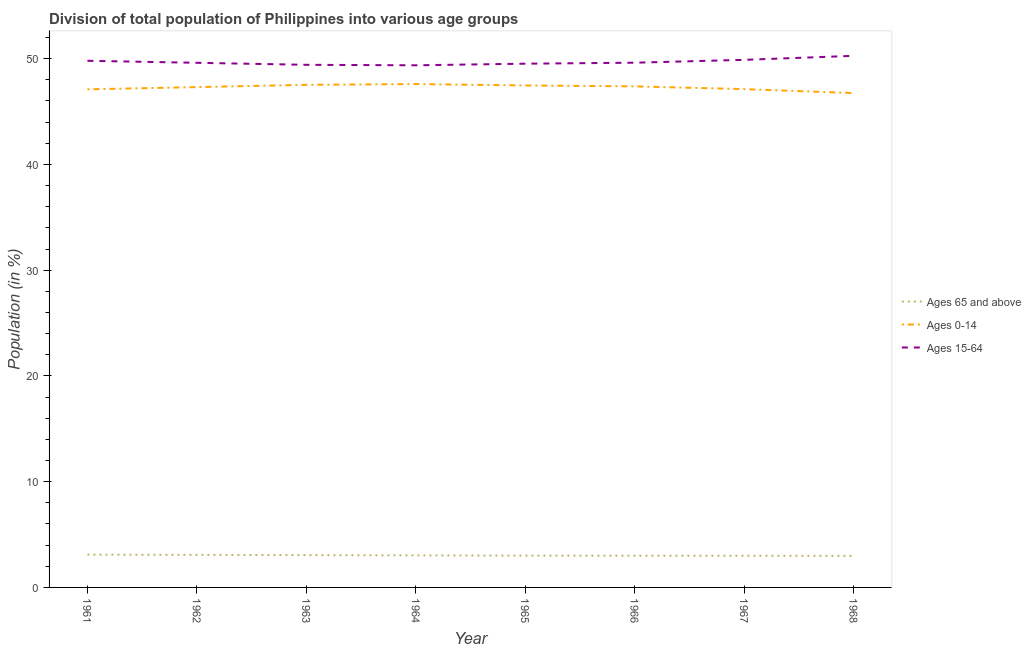Does the line corresponding to percentage of population within the age-group 15-64 intersect with the line corresponding to percentage of population within the age-group of 65 and above?
Make the answer very short. No. What is the percentage of population within the age-group 0-14 in 1964?
Offer a terse response. 47.6. Across all years, what is the maximum percentage of population within the age-group of 65 and above?
Your answer should be very brief. 3.1. Across all years, what is the minimum percentage of population within the age-group 0-14?
Your answer should be very brief. 46.75. In which year was the percentage of population within the age-group 15-64 maximum?
Your response must be concise. 1968. In which year was the percentage of population within the age-group 0-14 minimum?
Offer a terse response. 1968. What is the total percentage of population within the age-group of 65 and above in the graph?
Give a very brief answer. 24.25. What is the difference between the percentage of population within the age-group 0-14 in 1961 and that in 1963?
Offer a very short reply. -0.43. What is the difference between the percentage of population within the age-group 0-14 in 1967 and the percentage of population within the age-group 15-64 in 1964?
Offer a terse response. -2.25. What is the average percentage of population within the age-group 15-64 per year?
Provide a short and direct response. 49.69. In the year 1966, what is the difference between the percentage of population within the age-group 0-14 and percentage of population within the age-group of 65 and above?
Give a very brief answer. 44.38. In how many years, is the percentage of population within the age-group 0-14 greater than 50 %?
Offer a very short reply. 0. What is the ratio of the percentage of population within the age-group 15-64 in 1963 to that in 1965?
Ensure brevity in your answer.  1. What is the difference between the highest and the second highest percentage of population within the age-group 15-64?
Your response must be concise. 0.38. What is the difference between the highest and the lowest percentage of population within the age-group 0-14?
Your answer should be compact. 0.85. Is the sum of the percentage of population within the age-group 15-64 in 1967 and 1968 greater than the maximum percentage of population within the age-group 0-14 across all years?
Keep it short and to the point. Yes. Does the percentage of population within the age-group of 65 and above monotonically increase over the years?
Ensure brevity in your answer.  No. How many lines are there?
Offer a terse response. 3. Are the values on the major ticks of Y-axis written in scientific E-notation?
Keep it short and to the point. No. Does the graph contain any zero values?
Ensure brevity in your answer.  No. Does the graph contain grids?
Your response must be concise. No. Where does the legend appear in the graph?
Ensure brevity in your answer.  Center right. What is the title of the graph?
Provide a short and direct response. Division of total population of Philippines into various age groups
. What is the label or title of the X-axis?
Your response must be concise. Year. What is the label or title of the Y-axis?
Provide a short and direct response. Population (in %). What is the Population (in %) in Ages 65 and above in 1961?
Provide a short and direct response. 3.1. What is the Population (in %) of Ages 0-14 in 1961?
Offer a very short reply. 47.1. What is the Population (in %) of Ages 15-64 in 1961?
Offer a terse response. 49.8. What is the Population (in %) in Ages 65 and above in 1962?
Your answer should be very brief. 3.08. What is the Population (in %) in Ages 0-14 in 1962?
Offer a very short reply. 47.31. What is the Population (in %) in Ages 15-64 in 1962?
Your answer should be compact. 49.61. What is the Population (in %) in Ages 65 and above in 1963?
Your answer should be very brief. 3.06. What is the Population (in %) in Ages 0-14 in 1963?
Your answer should be compact. 47.53. What is the Population (in %) of Ages 15-64 in 1963?
Provide a succinct answer. 49.42. What is the Population (in %) in Ages 65 and above in 1964?
Provide a succinct answer. 3.03. What is the Population (in %) of Ages 0-14 in 1964?
Provide a short and direct response. 47.6. What is the Population (in %) in Ages 15-64 in 1964?
Your answer should be very brief. 49.37. What is the Population (in %) in Ages 65 and above in 1965?
Offer a very short reply. 3.01. What is the Population (in %) in Ages 0-14 in 1965?
Provide a short and direct response. 47.47. What is the Population (in %) in Ages 15-64 in 1965?
Your answer should be very brief. 49.53. What is the Population (in %) in Ages 65 and above in 1966?
Give a very brief answer. 3. What is the Population (in %) in Ages 0-14 in 1966?
Give a very brief answer. 47.38. What is the Population (in %) of Ages 15-64 in 1966?
Provide a succinct answer. 49.62. What is the Population (in %) of Ages 65 and above in 1967?
Offer a terse response. 2.99. What is the Population (in %) in Ages 0-14 in 1967?
Your answer should be very brief. 47.12. What is the Population (in %) of Ages 15-64 in 1967?
Ensure brevity in your answer.  49.89. What is the Population (in %) in Ages 65 and above in 1968?
Provide a short and direct response. 2.99. What is the Population (in %) of Ages 0-14 in 1968?
Your response must be concise. 46.75. What is the Population (in %) in Ages 15-64 in 1968?
Keep it short and to the point. 50.27. Across all years, what is the maximum Population (in %) in Ages 65 and above?
Provide a succinct answer. 3.1. Across all years, what is the maximum Population (in %) in Ages 0-14?
Provide a short and direct response. 47.6. Across all years, what is the maximum Population (in %) in Ages 15-64?
Offer a very short reply. 50.27. Across all years, what is the minimum Population (in %) of Ages 65 and above?
Ensure brevity in your answer.  2.99. Across all years, what is the minimum Population (in %) of Ages 0-14?
Provide a short and direct response. 46.75. Across all years, what is the minimum Population (in %) in Ages 15-64?
Ensure brevity in your answer.  49.37. What is the total Population (in %) of Ages 65 and above in the graph?
Provide a succinct answer. 24.25. What is the total Population (in %) of Ages 0-14 in the graph?
Provide a short and direct response. 378.25. What is the total Population (in %) of Ages 15-64 in the graph?
Offer a terse response. 397.5. What is the difference between the Population (in %) of Ages 65 and above in 1961 and that in 1962?
Offer a very short reply. 0.02. What is the difference between the Population (in %) in Ages 0-14 in 1961 and that in 1962?
Make the answer very short. -0.21. What is the difference between the Population (in %) of Ages 15-64 in 1961 and that in 1962?
Your response must be concise. 0.19. What is the difference between the Population (in %) in Ages 65 and above in 1961 and that in 1963?
Make the answer very short. 0.04. What is the difference between the Population (in %) of Ages 0-14 in 1961 and that in 1963?
Offer a very short reply. -0.43. What is the difference between the Population (in %) of Ages 15-64 in 1961 and that in 1963?
Your response must be concise. 0.38. What is the difference between the Population (in %) of Ages 65 and above in 1961 and that in 1964?
Ensure brevity in your answer.  0.07. What is the difference between the Population (in %) of Ages 0-14 in 1961 and that in 1964?
Offer a terse response. -0.5. What is the difference between the Population (in %) in Ages 15-64 in 1961 and that in 1964?
Provide a succinct answer. 0.43. What is the difference between the Population (in %) of Ages 65 and above in 1961 and that in 1965?
Offer a very short reply. 0.09. What is the difference between the Population (in %) in Ages 0-14 in 1961 and that in 1965?
Your answer should be compact. -0.37. What is the difference between the Population (in %) in Ages 15-64 in 1961 and that in 1965?
Offer a very short reply. 0.28. What is the difference between the Population (in %) of Ages 65 and above in 1961 and that in 1966?
Keep it short and to the point. 0.1. What is the difference between the Population (in %) in Ages 0-14 in 1961 and that in 1966?
Give a very brief answer. -0.28. What is the difference between the Population (in %) in Ages 15-64 in 1961 and that in 1966?
Provide a short and direct response. 0.18. What is the difference between the Population (in %) in Ages 65 and above in 1961 and that in 1967?
Provide a short and direct response. 0.11. What is the difference between the Population (in %) of Ages 0-14 in 1961 and that in 1967?
Ensure brevity in your answer.  -0.02. What is the difference between the Population (in %) of Ages 15-64 in 1961 and that in 1967?
Offer a very short reply. -0.09. What is the difference between the Population (in %) in Ages 65 and above in 1961 and that in 1968?
Make the answer very short. 0.11. What is the difference between the Population (in %) of Ages 0-14 in 1961 and that in 1968?
Your response must be concise. 0.35. What is the difference between the Population (in %) in Ages 15-64 in 1961 and that in 1968?
Provide a succinct answer. -0.47. What is the difference between the Population (in %) in Ages 65 and above in 1962 and that in 1963?
Provide a succinct answer. 0.02. What is the difference between the Population (in %) of Ages 0-14 in 1962 and that in 1963?
Your answer should be compact. -0.21. What is the difference between the Population (in %) of Ages 15-64 in 1962 and that in 1963?
Make the answer very short. 0.19. What is the difference between the Population (in %) of Ages 65 and above in 1962 and that in 1964?
Keep it short and to the point. 0.05. What is the difference between the Population (in %) in Ages 0-14 in 1962 and that in 1964?
Provide a short and direct response. -0.29. What is the difference between the Population (in %) of Ages 15-64 in 1962 and that in 1964?
Ensure brevity in your answer.  0.24. What is the difference between the Population (in %) in Ages 65 and above in 1962 and that in 1965?
Provide a short and direct response. 0.07. What is the difference between the Population (in %) in Ages 0-14 in 1962 and that in 1965?
Your answer should be compact. -0.16. What is the difference between the Population (in %) of Ages 15-64 in 1962 and that in 1965?
Keep it short and to the point. 0.08. What is the difference between the Population (in %) of Ages 65 and above in 1962 and that in 1966?
Offer a very short reply. 0.08. What is the difference between the Population (in %) in Ages 0-14 in 1962 and that in 1966?
Your response must be concise. -0.07. What is the difference between the Population (in %) of Ages 15-64 in 1962 and that in 1966?
Your response must be concise. -0.01. What is the difference between the Population (in %) in Ages 65 and above in 1962 and that in 1967?
Provide a short and direct response. 0.09. What is the difference between the Population (in %) in Ages 0-14 in 1962 and that in 1967?
Make the answer very short. 0.19. What is the difference between the Population (in %) of Ages 15-64 in 1962 and that in 1967?
Keep it short and to the point. -0.28. What is the difference between the Population (in %) of Ages 65 and above in 1962 and that in 1968?
Give a very brief answer. 0.09. What is the difference between the Population (in %) of Ages 0-14 in 1962 and that in 1968?
Ensure brevity in your answer.  0.57. What is the difference between the Population (in %) in Ages 15-64 in 1962 and that in 1968?
Make the answer very short. -0.66. What is the difference between the Population (in %) in Ages 65 and above in 1963 and that in 1964?
Your answer should be very brief. 0.03. What is the difference between the Population (in %) in Ages 0-14 in 1963 and that in 1964?
Keep it short and to the point. -0.07. What is the difference between the Population (in %) of Ages 15-64 in 1963 and that in 1964?
Provide a succinct answer. 0.05. What is the difference between the Population (in %) in Ages 65 and above in 1963 and that in 1965?
Provide a succinct answer. 0.05. What is the difference between the Population (in %) of Ages 0-14 in 1963 and that in 1965?
Give a very brief answer. 0.06. What is the difference between the Population (in %) of Ages 15-64 in 1963 and that in 1965?
Ensure brevity in your answer.  -0.11. What is the difference between the Population (in %) of Ages 65 and above in 1963 and that in 1966?
Offer a terse response. 0.05. What is the difference between the Population (in %) in Ages 0-14 in 1963 and that in 1966?
Provide a short and direct response. 0.15. What is the difference between the Population (in %) in Ages 15-64 in 1963 and that in 1966?
Offer a terse response. -0.2. What is the difference between the Population (in %) of Ages 65 and above in 1963 and that in 1967?
Offer a terse response. 0.06. What is the difference between the Population (in %) in Ages 0-14 in 1963 and that in 1967?
Offer a very short reply. 0.41. What is the difference between the Population (in %) in Ages 15-64 in 1963 and that in 1967?
Provide a succinct answer. -0.47. What is the difference between the Population (in %) in Ages 65 and above in 1963 and that in 1968?
Provide a succinct answer. 0.07. What is the difference between the Population (in %) of Ages 0-14 in 1963 and that in 1968?
Give a very brief answer. 0.78. What is the difference between the Population (in %) in Ages 15-64 in 1963 and that in 1968?
Make the answer very short. -0.85. What is the difference between the Population (in %) of Ages 65 and above in 1964 and that in 1965?
Provide a succinct answer. 0.02. What is the difference between the Population (in %) of Ages 0-14 in 1964 and that in 1965?
Ensure brevity in your answer.  0.13. What is the difference between the Population (in %) in Ages 15-64 in 1964 and that in 1965?
Keep it short and to the point. -0.15. What is the difference between the Population (in %) of Ages 65 and above in 1964 and that in 1966?
Your response must be concise. 0.03. What is the difference between the Population (in %) of Ages 0-14 in 1964 and that in 1966?
Your answer should be very brief. 0.22. What is the difference between the Population (in %) of Ages 15-64 in 1964 and that in 1966?
Ensure brevity in your answer.  -0.25. What is the difference between the Population (in %) in Ages 65 and above in 1964 and that in 1967?
Provide a succinct answer. 0.04. What is the difference between the Population (in %) of Ages 0-14 in 1964 and that in 1967?
Provide a succinct answer. 0.48. What is the difference between the Population (in %) in Ages 15-64 in 1964 and that in 1967?
Your answer should be very brief. -0.51. What is the difference between the Population (in %) in Ages 65 and above in 1964 and that in 1968?
Provide a short and direct response. 0.04. What is the difference between the Population (in %) of Ages 0-14 in 1964 and that in 1968?
Offer a terse response. 0.85. What is the difference between the Population (in %) in Ages 15-64 in 1964 and that in 1968?
Your answer should be compact. -0.9. What is the difference between the Population (in %) of Ages 65 and above in 1965 and that in 1966?
Give a very brief answer. 0.01. What is the difference between the Population (in %) in Ages 0-14 in 1965 and that in 1966?
Provide a succinct answer. 0.09. What is the difference between the Population (in %) in Ages 15-64 in 1965 and that in 1966?
Your answer should be compact. -0.09. What is the difference between the Population (in %) of Ages 65 and above in 1965 and that in 1967?
Keep it short and to the point. 0.01. What is the difference between the Population (in %) in Ages 0-14 in 1965 and that in 1967?
Your answer should be very brief. 0.35. What is the difference between the Population (in %) of Ages 15-64 in 1965 and that in 1967?
Your answer should be very brief. -0.36. What is the difference between the Population (in %) of Ages 65 and above in 1965 and that in 1968?
Offer a very short reply. 0.02. What is the difference between the Population (in %) of Ages 0-14 in 1965 and that in 1968?
Your response must be concise. 0.72. What is the difference between the Population (in %) of Ages 15-64 in 1965 and that in 1968?
Offer a terse response. -0.74. What is the difference between the Population (in %) of Ages 65 and above in 1966 and that in 1967?
Your answer should be compact. 0.01. What is the difference between the Population (in %) in Ages 0-14 in 1966 and that in 1967?
Offer a very short reply. 0.26. What is the difference between the Population (in %) of Ages 15-64 in 1966 and that in 1967?
Offer a terse response. -0.27. What is the difference between the Population (in %) of Ages 65 and above in 1966 and that in 1968?
Keep it short and to the point. 0.02. What is the difference between the Population (in %) in Ages 0-14 in 1966 and that in 1968?
Keep it short and to the point. 0.63. What is the difference between the Population (in %) of Ages 15-64 in 1966 and that in 1968?
Your answer should be very brief. -0.65. What is the difference between the Population (in %) of Ages 65 and above in 1967 and that in 1968?
Offer a very short reply. 0.01. What is the difference between the Population (in %) of Ages 0-14 in 1967 and that in 1968?
Your response must be concise. 0.37. What is the difference between the Population (in %) in Ages 15-64 in 1967 and that in 1968?
Offer a very short reply. -0.38. What is the difference between the Population (in %) in Ages 65 and above in 1961 and the Population (in %) in Ages 0-14 in 1962?
Offer a very short reply. -44.21. What is the difference between the Population (in %) of Ages 65 and above in 1961 and the Population (in %) of Ages 15-64 in 1962?
Your answer should be compact. -46.51. What is the difference between the Population (in %) of Ages 0-14 in 1961 and the Population (in %) of Ages 15-64 in 1962?
Your response must be concise. -2.51. What is the difference between the Population (in %) of Ages 65 and above in 1961 and the Population (in %) of Ages 0-14 in 1963?
Ensure brevity in your answer.  -44.43. What is the difference between the Population (in %) in Ages 65 and above in 1961 and the Population (in %) in Ages 15-64 in 1963?
Your answer should be compact. -46.32. What is the difference between the Population (in %) of Ages 0-14 in 1961 and the Population (in %) of Ages 15-64 in 1963?
Provide a succinct answer. -2.32. What is the difference between the Population (in %) in Ages 65 and above in 1961 and the Population (in %) in Ages 0-14 in 1964?
Provide a succinct answer. -44.5. What is the difference between the Population (in %) in Ages 65 and above in 1961 and the Population (in %) in Ages 15-64 in 1964?
Provide a succinct answer. -46.27. What is the difference between the Population (in %) of Ages 0-14 in 1961 and the Population (in %) of Ages 15-64 in 1964?
Your answer should be compact. -2.27. What is the difference between the Population (in %) of Ages 65 and above in 1961 and the Population (in %) of Ages 0-14 in 1965?
Your answer should be compact. -44.37. What is the difference between the Population (in %) of Ages 65 and above in 1961 and the Population (in %) of Ages 15-64 in 1965?
Offer a terse response. -46.43. What is the difference between the Population (in %) in Ages 0-14 in 1961 and the Population (in %) in Ages 15-64 in 1965?
Make the answer very short. -2.42. What is the difference between the Population (in %) in Ages 65 and above in 1961 and the Population (in %) in Ages 0-14 in 1966?
Provide a succinct answer. -44.28. What is the difference between the Population (in %) of Ages 65 and above in 1961 and the Population (in %) of Ages 15-64 in 1966?
Give a very brief answer. -46.52. What is the difference between the Population (in %) in Ages 0-14 in 1961 and the Population (in %) in Ages 15-64 in 1966?
Offer a very short reply. -2.52. What is the difference between the Population (in %) of Ages 65 and above in 1961 and the Population (in %) of Ages 0-14 in 1967?
Provide a short and direct response. -44.02. What is the difference between the Population (in %) of Ages 65 and above in 1961 and the Population (in %) of Ages 15-64 in 1967?
Your answer should be very brief. -46.79. What is the difference between the Population (in %) of Ages 0-14 in 1961 and the Population (in %) of Ages 15-64 in 1967?
Your answer should be very brief. -2.79. What is the difference between the Population (in %) in Ages 65 and above in 1961 and the Population (in %) in Ages 0-14 in 1968?
Give a very brief answer. -43.65. What is the difference between the Population (in %) of Ages 65 and above in 1961 and the Population (in %) of Ages 15-64 in 1968?
Provide a succinct answer. -47.17. What is the difference between the Population (in %) in Ages 0-14 in 1961 and the Population (in %) in Ages 15-64 in 1968?
Give a very brief answer. -3.17. What is the difference between the Population (in %) in Ages 65 and above in 1962 and the Population (in %) in Ages 0-14 in 1963?
Offer a very short reply. -44.45. What is the difference between the Population (in %) of Ages 65 and above in 1962 and the Population (in %) of Ages 15-64 in 1963?
Give a very brief answer. -46.34. What is the difference between the Population (in %) in Ages 0-14 in 1962 and the Population (in %) in Ages 15-64 in 1963?
Make the answer very short. -2.11. What is the difference between the Population (in %) in Ages 65 and above in 1962 and the Population (in %) in Ages 0-14 in 1964?
Keep it short and to the point. -44.52. What is the difference between the Population (in %) in Ages 65 and above in 1962 and the Population (in %) in Ages 15-64 in 1964?
Offer a very short reply. -46.29. What is the difference between the Population (in %) of Ages 0-14 in 1962 and the Population (in %) of Ages 15-64 in 1964?
Your response must be concise. -2.06. What is the difference between the Population (in %) of Ages 65 and above in 1962 and the Population (in %) of Ages 0-14 in 1965?
Offer a very short reply. -44.39. What is the difference between the Population (in %) in Ages 65 and above in 1962 and the Population (in %) in Ages 15-64 in 1965?
Your answer should be very brief. -46.45. What is the difference between the Population (in %) in Ages 0-14 in 1962 and the Population (in %) in Ages 15-64 in 1965?
Make the answer very short. -2.21. What is the difference between the Population (in %) of Ages 65 and above in 1962 and the Population (in %) of Ages 0-14 in 1966?
Provide a short and direct response. -44.3. What is the difference between the Population (in %) in Ages 65 and above in 1962 and the Population (in %) in Ages 15-64 in 1966?
Provide a short and direct response. -46.54. What is the difference between the Population (in %) of Ages 0-14 in 1962 and the Population (in %) of Ages 15-64 in 1966?
Make the answer very short. -2.31. What is the difference between the Population (in %) in Ages 65 and above in 1962 and the Population (in %) in Ages 0-14 in 1967?
Ensure brevity in your answer.  -44.04. What is the difference between the Population (in %) of Ages 65 and above in 1962 and the Population (in %) of Ages 15-64 in 1967?
Your answer should be compact. -46.81. What is the difference between the Population (in %) of Ages 0-14 in 1962 and the Population (in %) of Ages 15-64 in 1967?
Your answer should be very brief. -2.58. What is the difference between the Population (in %) of Ages 65 and above in 1962 and the Population (in %) of Ages 0-14 in 1968?
Provide a short and direct response. -43.67. What is the difference between the Population (in %) of Ages 65 and above in 1962 and the Population (in %) of Ages 15-64 in 1968?
Offer a terse response. -47.19. What is the difference between the Population (in %) of Ages 0-14 in 1962 and the Population (in %) of Ages 15-64 in 1968?
Your answer should be very brief. -2.96. What is the difference between the Population (in %) in Ages 65 and above in 1963 and the Population (in %) in Ages 0-14 in 1964?
Your answer should be very brief. -44.54. What is the difference between the Population (in %) in Ages 65 and above in 1963 and the Population (in %) in Ages 15-64 in 1964?
Keep it short and to the point. -46.32. What is the difference between the Population (in %) in Ages 0-14 in 1963 and the Population (in %) in Ages 15-64 in 1964?
Provide a short and direct response. -1.85. What is the difference between the Population (in %) of Ages 65 and above in 1963 and the Population (in %) of Ages 0-14 in 1965?
Your response must be concise. -44.41. What is the difference between the Population (in %) in Ages 65 and above in 1963 and the Population (in %) in Ages 15-64 in 1965?
Your response must be concise. -46.47. What is the difference between the Population (in %) of Ages 0-14 in 1963 and the Population (in %) of Ages 15-64 in 1965?
Your answer should be very brief. -2. What is the difference between the Population (in %) of Ages 65 and above in 1963 and the Population (in %) of Ages 0-14 in 1966?
Offer a terse response. -44.32. What is the difference between the Population (in %) of Ages 65 and above in 1963 and the Population (in %) of Ages 15-64 in 1966?
Give a very brief answer. -46.56. What is the difference between the Population (in %) of Ages 0-14 in 1963 and the Population (in %) of Ages 15-64 in 1966?
Provide a short and direct response. -2.09. What is the difference between the Population (in %) of Ages 65 and above in 1963 and the Population (in %) of Ages 0-14 in 1967?
Your response must be concise. -44.06. What is the difference between the Population (in %) of Ages 65 and above in 1963 and the Population (in %) of Ages 15-64 in 1967?
Make the answer very short. -46.83. What is the difference between the Population (in %) in Ages 0-14 in 1963 and the Population (in %) in Ages 15-64 in 1967?
Offer a very short reply. -2.36. What is the difference between the Population (in %) of Ages 65 and above in 1963 and the Population (in %) of Ages 0-14 in 1968?
Your answer should be very brief. -43.69. What is the difference between the Population (in %) in Ages 65 and above in 1963 and the Population (in %) in Ages 15-64 in 1968?
Provide a short and direct response. -47.21. What is the difference between the Population (in %) of Ages 0-14 in 1963 and the Population (in %) of Ages 15-64 in 1968?
Your answer should be compact. -2.74. What is the difference between the Population (in %) of Ages 65 and above in 1964 and the Population (in %) of Ages 0-14 in 1965?
Your answer should be very brief. -44.44. What is the difference between the Population (in %) in Ages 65 and above in 1964 and the Population (in %) in Ages 15-64 in 1965?
Your answer should be very brief. -46.49. What is the difference between the Population (in %) of Ages 0-14 in 1964 and the Population (in %) of Ages 15-64 in 1965?
Offer a terse response. -1.93. What is the difference between the Population (in %) in Ages 65 and above in 1964 and the Population (in %) in Ages 0-14 in 1966?
Your answer should be very brief. -44.35. What is the difference between the Population (in %) in Ages 65 and above in 1964 and the Population (in %) in Ages 15-64 in 1966?
Give a very brief answer. -46.59. What is the difference between the Population (in %) in Ages 0-14 in 1964 and the Population (in %) in Ages 15-64 in 1966?
Keep it short and to the point. -2.02. What is the difference between the Population (in %) in Ages 65 and above in 1964 and the Population (in %) in Ages 0-14 in 1967?
Your answer should be very brief. -44.09. What is the difference between the Population (in %) in Ages 65 and above in 1964 and the Population (in %) in Ages 15-64 in 1967?
Provide a succinct answer. -46.86. What is the difference between the Population (in %) of Ages 0-14 in 1964 and the Population (in %) of Ages 15-64 in 1967?
Make the answer very short. -2.29. What is the difference between the Population (in %) of Ages 65 and above in 1964 and the Population (in %) of Ages 0-14 in 1968?
Your response must be concise. -43.72. What is the difference between the Population (in %) of Ages 65 and above in 1964 and the Population (in %) of Ages 15-64 in 1968?
Provide a short and direct response. -47.24. What is the difference between the Population (in %) of Ages 0-14 in 1964 and the Population (in %) of Ages 15-64 in 1968?
Your response must be concise. -2.67. What is the difference between the Population (in %) in Ages 65 and above in 1965 and the Population (in %) in Ages 0-14 in 1966?
Offer a very short reply. -44.37. What is the difference between the Population (in %) in Ages 65 and above in 1965 and the Population (in %) in Ages 15-64 in 1966?
Your answer should be very brief. -46.61. What is the difference between the Population (in %) in Ages 0-14 in 1965 and the Population (in %) in Ages 15-64 in 1966?
Offer a terse response. -2.15. What is the difference between the Population (in %) of Ages 65 and above in 1965 and the Population (in %) of Ages 0-14 in 1967?
Give a very brief answer. -44.11. What is the difference between the Population (in %) of Ages 65 and above in 1965 and the Population (in %) of Ages 15-64 in 1967?
Provide a succinct answer. -46.88. What is the difference between the Population (in %) of Ages 0-14 in 1965 and the Population (in %) of Ages 15-64 in 1967?
Your response must be concise. -2.42. What is the difference between the Population (in %) in Ages 65 and above in 1965 and the Population (in %) in Ages 0-14 in 1968?
Your answer should be compact. -43.74. What is the difference between the Population (in %) of Ages 65 and above in 1965 and the Population (in %) of Ages 15-64 in 1968?
Provide a short and direct response. -47.26. What is the difference between the Population (in %) of Ages 0-14 in 1965 and the Population (in %) of Ages 15-64 in 1968?
Your response must be concise. -2.8. What is the difference between the Population (in %) in Ages 65 and above in 1966 and the Population (in %) in Ages 0-14 in 1967?
Your answer should be compact. -44.12. What is the difference between the Population (in %) in Ages 65 and above in 1966 and the Population (in %) in Ages 15-64 in 1967?
Provide a short and direct response. -46.89. What is the difference between the Population (in %) in Ages 0-14 in 1966 and the Population (in %) in Ages 15-64 in 1967?
Your answer should be compact. -2.51. What is the difference between the Population (in %) in Ages 65 and above in 1966 and the Population (in %) in Ages 0-14 in 1968?
Offer a very short reply. -43.74. What is the difference between the Population (in %) of Ages 65 and above in 1966 and the Population (in %) of Ages 15-64 in 1968?
Give a very brief answer. -47.27. What is the difference between the Population (in %) of Ages 0-14 in 1966 and the Population (in %) of Ages 15-64 in 1968?
Make the answer very short. -2.89. What is the difference between the Population (in %) in Ages 65 and above in 1967 and the Population (in %) in Ages 0-14 in 1968?
Provide a succinct answer. -43.75. What is the difference between the Population (in %) in Ages 65 and above in 1967 and the Population (in %) in Ages 15-64 in 1968?
Offer a terse response. -47.28. What is the difference between the Population (in %) in Ages 0-14 in 1967 and the Population (in %) in Ages 15-64 in 1968?
Your response must be concise. -3.15. What is the average Population (in %) of Ages 65 and above per year?
Offer a terse response. 3.03. What is the average Population (in %) of Ages 0-14 per year?
Provide a succinct answer. 47.28. What is the average Population (in %) of Ages 15-64 per year?
Offer a terse response. 49.69. In the year 1961, what is the difference between the Population (in %) in Ages 65 and above and Population (in %) in Ages 0-14?
Offer a terse response. -44. In the year 1961, what is the difference between the Population (in %) in Ages 65 and above and Population (in %) in Ages 15-64?
Ensure brevity in your answer.  -46.7. In the year 1961, what is the difference between the Population (in %) of Ages 0-14 and Population (in %) of Ages 15-64?
Provide a short and direct response. -2.7. In the year 1962, what is the difference between the Population (in %) of Ages 65 and above and Population (in %) of Ages 0-14?
Your response must be concise. -44.23. In the year 1962, what is the difference between the Population (in %) of Ages 65 and above and Population (in %) of Ages 15-64?
Your answer should be very brief. -46.53. In the year 1962, what is the difference between the Population (in %) in Ages 0-14 and Population (in %) in Ages 15-64?
Your response must be concise. -2.3. In the year 1963, what is the difference between the Population (in %) in Ages 65 and above and Population (in %) in Ages 0-14?
Your response must be concise. -44.47. In the year 1963, what is the difference between the Population (in %) of Ages 65 and above and Population (in %) of Ages 15-64?
Provide a succinct answer. -46.36. In the year 1963, what is the difference between the Population (in %) in Ages 0-14 and Population (in %) in Ages 15-64?
Keep it short and to the point. -1.89. In the year 1964, what is the difference between the Population (in %) of Ages 65 and above and Population (in %) of Ages 0-14?
Provide a short and direct response. -44.57. In the year 1964, what is the difference between the Population (in %) of Ages 65 and above and Population (in %) of Ages 15-64?
Give a very brief answer. -46.34. In the year 1964, what is the difference between the Population (in %) in Ages 0-14 and Population (in %) in Ages 15-64?
Provide a succinct answer. -1.78. In the year 1965, what is the difference between the Population (in %) in Ages 65 and above and Population (in %) in Ages 0-14?
Provide a short and direct response. -44.46. In the year 1965, what is the difference between the Population (in %) of Ages 65 and above and Population (in %) of Ages 15-64?
Offer a very short reply. -46.52. In the year 1965, what is the difference between the Population (in %) of Ages 0-14 and Population (in %) of Ages 15-64?
Provide a short and direct response. -2.06. In the year 1966, what is the difference between the Population (in %) of Ages 65 and above and Population (in %) of Ages 0-14?
Your answer should be very brief. -44.38. In the year 1966, what is the difference between the Population (in %) of Ages 65 and above and Population (in %) of Ages 15-64?
Give a very brief answer. -46.62. In the year 1966, what is the difference between the Population (in %) of Ages 0-14 and Population (in %) of Ages 15-64?
Keep it short and to the point. -2.24. In the year 1967, what is the difference between the Population (in %) in Ages 65 and above and Population (in %) in Ages 0-14?
Offer a terse response. -44.13. In the year 1967, what is the difference between the Population (in %) in Ages 65 and above and Population (in %) in Ages 15-64?
Offer a very short reply. -46.9. In the year 1967, what is the difference between the Population (in %) in Ages 0-14 and Population (in %) in Ages 15-64?
Provide a short and direct response. -2.77. In the year 1968, what is the difference between the Population (in %) in Ages 65 and above and Population (in %) in Ages 0-14?
Offer a very short reply. -43.76. In the year 1968, what is the difference between the Population (in %) in Ages 65 and above and Population (in %) in Ages 15-64?
Provide a succinct answer. -47.28. In the year 1968, what is the difference between the Population (in %) in Ages 0-14 and Population (in %) in Ages 15-64?
Provide a succinct answer. -3.52. What is the ratio of the Population (in %) of Ages 0-14 in 1961 to that in 1962?
Your response must be concise. 1. What is the ratio of the Population (in %) in Ages 15-64 in 1961 to that in 1962?
Make the answer very short. 1. What is the ratio of the Population (in %) in Ages 65 and above in 1961 to that in 1963?
Offer a very short reply. 1.01. What is the ratio of the Population (in %) in Ages 0-14 in 1961 to that in 1963?
Keep it short and to the point. 0.99. What is the ratio of the Population (in %) in Ages 15-64 in 1961 to that in 1963?
Make the answer very short. 1.01. What is the ratio of the Population (in %) in Ages 65 and above in 1961 to that in 1964?
Your answer should be compact. 1.02. What is the ratio of the Population (in %) of Ages 15-64 in 1961 to that in 1964?
Provide a short and direct response. 1.01. What is the ratio of the Population (in %) in Ages 65 and above in 1961 to that in 1965?
Your answer should be compact. 1.03. What is the ratio of the Population (in %) in Ages 0-14 in 1961 to that in 1965?
Make the answer very short. 0.99. What is the ratio of the Population (in %) in Ages 15-64 in 1961 to that in 1965?
Provide a short and direct response. 1.01. What is the ratio of the Population (in %) of Ages 65 and above in 1961 to that in 1966?
Make the answer very short. 1.03. What is the ratio of the Population (in %) of Ages 0-14 in 1961 to that in 1966?
Your response must be concise. 0.99. What is the ratio of the Population (in %) in Ages 15-64 in 1961 to that in 1966?
Offer a very short reply. 1. What is the ratio of the Population (in %) in Ages 65 and above in 1961 to that in 1967?
Offer a very short reply. 1.04. What is the ratio of the Population (in %) in Ages 0-14 in 1961 to that in 1967?
Give a very brief answer. 1. What is the ratio of the Population (in %) of Ages 15-64 in 1961 to that in 1967?
Your answer should be very brief. 1. What is the ratio of the Population (in %) in Ages 65 and above in 1961 to that in 1968?
Your answer should be compact. 1.04. What is the ratio of the Population (in %) of Ages 0-14 in 1961 to that in 1968?
Make the answer very short. 1.01. What is the ratio of the Population (in %) in Ages 15-64 in 1961 to that in 1968?
Offer a terse response. 0.99. What is the ratio of the Population (in %) in Ages 65 and above in 1962 to that in 1963?
Make the answer very short. 1.01. What is the ratio of the Population (in %) of Ages 0-14 in 1962 to that in 1963?
Keep it short and to the point. 1. What is the ratio of the Population (in %) of Ages 65 and above in 1962 to that in 1964?
Make the answer very short. 1.02. What is the ratio of the Population (in %) of Ages 0-14 in 1962 to that in 1964?
Your answer should be very brief. 0.99. What is the ratio of the Population (in %) of Ages 15-64 in 1962 to that in 1964?
Ensure brevity in your answer.  1. What is the ratio of the Population (in %) of Ages 65 and above in 1962 to that in 1965?
Your answer should be compact. 1.02. What is the ratio of the Population (in %) of Ages 65 and above in 1962 to that in 1966?
Provide a short and direct response. 1.03. What is the ratio of the Population (in %) of Ages 65 and above in 1962 to that in 1967?
Provide a short and direct response. 1.03. What is the ratio of the Population (in %) of Ages 15-64 in 1962 to that in 1967?
Keep it short and to the point. 0.99. What is the ratio of the Population (in %) in Ages 65 and above in 1962 to that in 1968?
Give a very brief answer. 1.03. What is the ratio of the Population (in %) of Ages 0-14 in 1962 to that in 1968?
Offer a very short reply. 1.01. What is the ratio of the Population (in %) in Ages 15-64 in 1962 to that in 1968?
Keep it short and to the point. 0.99. What is the ratio of the Population (in %) in Ages 65 and above in 1963 to that in 1964?
Your answer should be compact. 1.01. What is the ratio of the Population (in %) of Ages 0-14 in 1963 to that in 1964?
Ensure brevity in your answer.  1. What is the ratio of the Population (in %) of Ages 15-64 in 1963 to that in 1964?
Your answer should be compact. 1. What is the ratio of the Population (in %) of Ages 65 and above in 1963 to that in 1965?
Your response must be concise. 1.02. What is the ratio of the Population (in %) in Ages 0-14 in 1963 to that in 1965?
Give a very brief answer. 1. What is the ratio of the Population (in %) in Ages 15-64 in 1963 to that in 1966?
Ensure brevity in your answer.  1. What is the ratio of the Population (in %) of Ages 65 and above in 1963 to that in 1967?
Provide a succinct answer. 1.02. What is the ratio of the Population (in %) in Ages 0-14 in 1963 to that in 1967?
Offer a terse response. 1.01. What is the ratio of the Population (in %) in Ages 15-64 in 1963 to that in 1967?
Your answer should be very brief. 0.99. What is the ratio of the Population (in %) of Ages 65 and above in 1963 to that in 1968?
Make the answer very short. 1.02. What is the ratio of the Population (in %) of Ages 0-14 in 1963 to that in 1968?
Your answer should be compact. 1.02. What is the ratio of the Population (in %) in Ages 15-64 in 1963 to that in 1968?
Offer a terse response. 0.98. What is the ratio of the Population (in %) of Ages 65 and above in 1964 to that in 1965?
Keep it short and to the point. 1.01. What is the ratio of the Population (in %) in Ages 15-64 in 1964 to that in 1965?
Provide a short and direct response. 1. What is the ratio of the Population (in %) in Ages 65 and above in 1964 to that in 1966?
Provide a short and direct response. 1.01. What is the ratio of the Population (in %) in Ages 15-64 in 1964 to that in 1966?
Your answer should be very brief. 0.99. What is the ratio of the Population (in %) of Ages 65 and above in 1964 to that in 1967?
Offer a terse response. 1.01. What is the ratio of the Population (in %) in Ages 0-14 in 1964 to that in 1967?
Offer a very short reply. 1.01. What is the ratio of the Population (in %) in Ages 15-64 in 1964 to that in 1967?
Give a very brief answer. 0.99. What is the ratio of the Population (in %) of Ages 65 and above in 1964 to that in 1968?
Make the answer very short. 1.01. What is the ratio of the Population (in %) in Ages 0-14 in 1964 to that in 1968?
Offer a very short reply. 1.02. What is the ratio of the Population (in %) of Ages 15-64 in 1964 to that in 1968?
Your response must be concise. 0.98. What is the ratio of the Population (in %) of Ages 65 and above in 1965 to that in 1966?
Your answer should be compact. 1. What is the ratio of the Population (in %) in Ages 15-64 in 1965 to that in 1966?
Provide a succinct answer. 1. What is the ratio of the Population (in %) of Ages 0-14 in 1965 to that in 1967?
Offer a very short reply. 1.01. What is the ratio of the Population (in %) of Ages 15-64 in 1965 to that in 1967?
Offer a very short reply. 0.99. What is the ratio of the Population (in %) in Ages 65 and above in 1965 to that in 1968?
Your answer should be compact. 1.01. What is the ratio of the Population (in %) in Ages 0-14 in 1965 to that in 1968?
Make the answer very short. 1.02. What is the ratio of the Population (in %) of Ages 15-64 in 1965 to that in 1968?
Your response must be concise. 0.99. What is the ratio of the Population (in %) of Ages 0-14 in 1966 to that in 1967?
Offer a very short reply. 1.01. What is the ratio of the Population (in %) of Ages 15-64 in 1966 to that in 1967?
Your response must be concise. 0.99. What is the ratio of the Population (in %) of Ages 65 and above in 1966 to that in 1968?
Provide a succinct answer. 1.01. What is the ratio of the Population (in %) of Ages 0-14 in 1966 to that in 1968?
Ensure brevity in your answer.  1.01. What is the ratio of the Population (in %) in Ages 15-64 in 1966 to that in 1968?
Your response must be concise. 0.99. What is the ratio of the Population (in %) of Ages 65 and above in 1967 to that in 1968?
Your response must be concise. 1. What is the ratio of the Population (in %) in Ages 15-64 in 1967 to that in 1968?
Provide a short and direct response. 0.99. What is the difference between the highest and the second highest Population (in %) of Ages 65 and above?
Keep it short and to the point. 0.02. What is the difference between the highest and the second highest Population (in %) in Ages 0-14?
Offer a terse response. 0.07. What is the difference between the highest and the second highest Population (in %) of Ages 15-64?
Keep it short and to the point. 0.38. What is the difference between the highest and the lowest Population (in %) in Ages 65 and above?
Offer a terse response. 0.11. What is the difference between the highest and the lowest Population (in %) in Ages 0-14?
Keep it short and to the point. 0.85. What is the difference between the highest and the lowest Population (in %) in Ages 15-64?
Offer a very short reply. 0.9. 